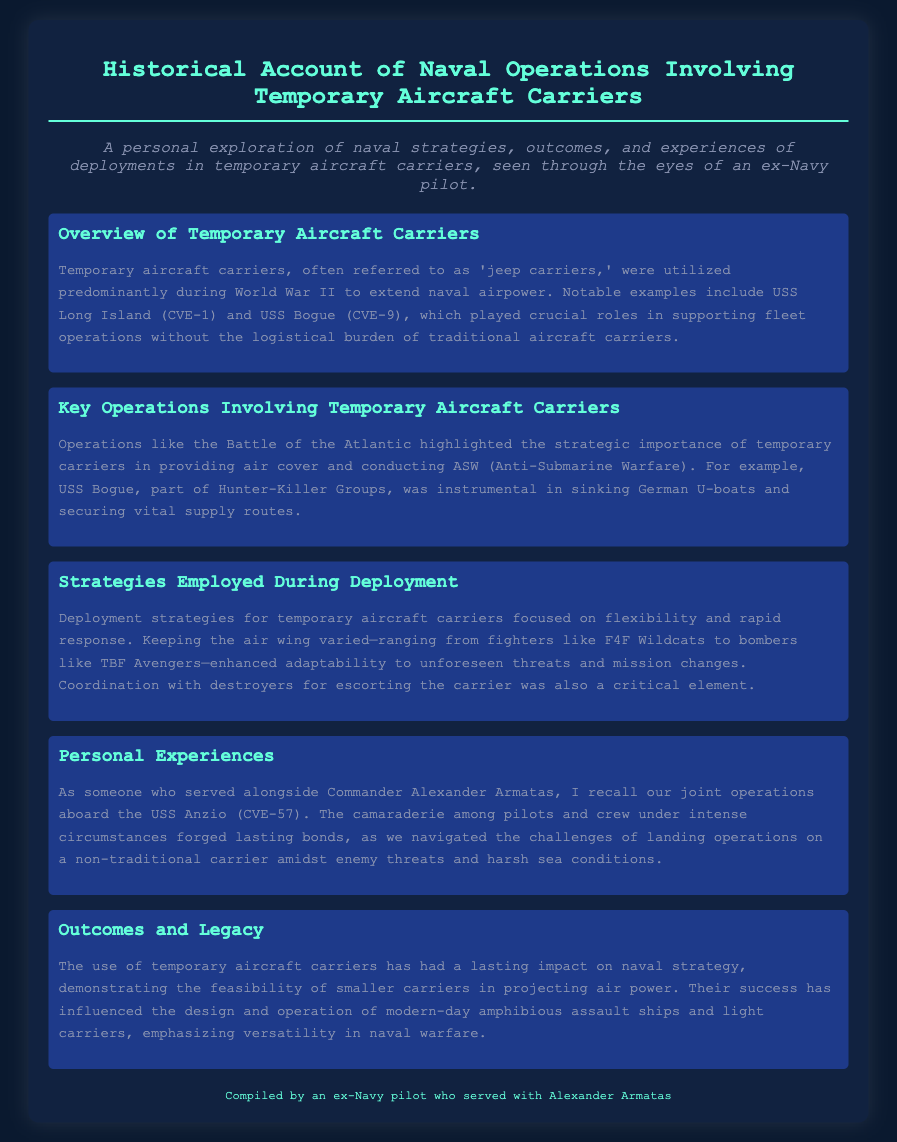What are temporary aircraft carriers often referred to as? Temporary aircraft carriers are commonly known as 'jeep carriers'.
Answer: jeep carriers Name one notable example of a temporary aircraft carrier. The document mentions USS Long Island as a notable example of a temporary aircraft carrier.
Answer: USS Long Island What strategic role did USS Bogue play during the Battle of the Atlantic? USS Bogue was instrumental in sinking German U-boats and securing vital supply routes.
Answer: sinking German U-boats What was a key focus of deployment strategies for temporary aircraft carriers? Deployment strategies for temporary aircraft carriers focused on flexibility and rapid response.
Answer: flexibility and rapid response Who did the author serve alongside while aboard the USS Anzio? The author served alongside Commander Alexander Armatas.
Answer: Commander Alexander Armatas What type of fighter is mentioned in the document as part of the air wing? The F4F Wildcat is mentioned as a fighter in the air wing.
Answer: F4F Wildcat What impact did temporary aircraft carriers have on modern naval strategy? They demonstrated the feasibility of smaller carriers in projecting air power.
Answer: feasibility of smaller carriers Which operations were highlighted for the strategic importance of temporary carriers? The document highlights the Battle of the Atlantic as showcasing the strategic importance.
Answer: Battle of the Atlantic 